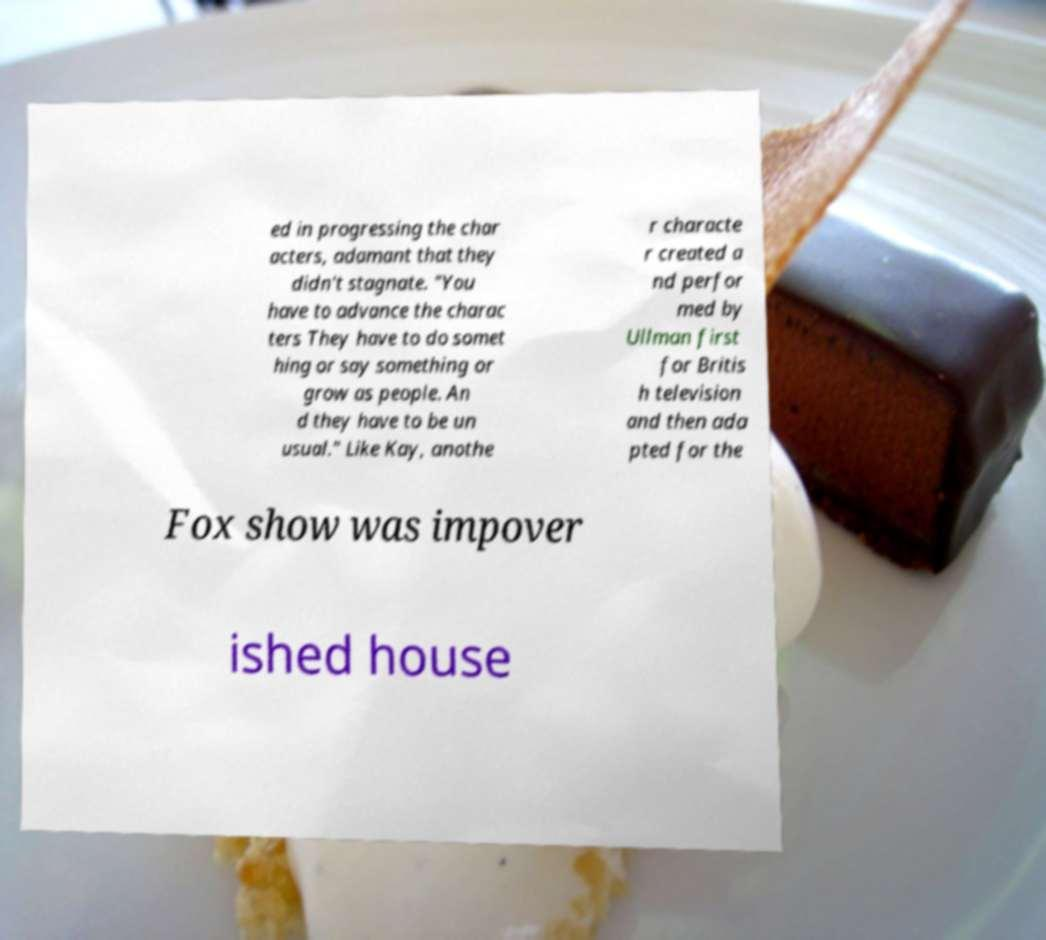Please identify and transcribe the text found in this image. ed in progressing the char acters, adamant that they didn't stagnate. "You have to advance the charac ters They have to do somet hing or say something or grow as people. An d they have to be un usual." Like Kay, anothe r characte r created a nd perfor med by Ullman first for Britis h television and then ada pted for the Fox show was impover ished house 